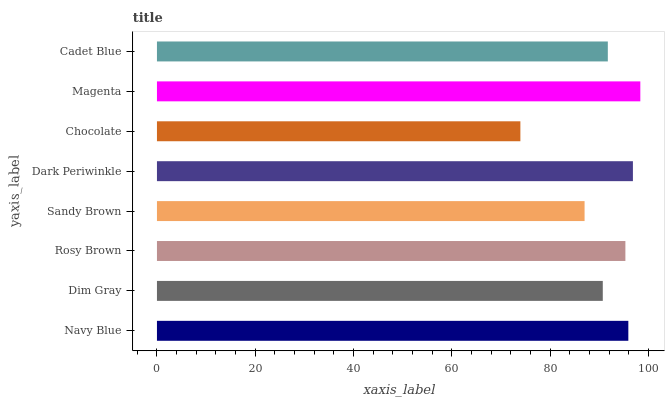Is Chocolate the minimum?
Answer yes or no. Yes. Is Magenta the maximum?
Answer yes or no. Yes. Is Dim Gray the minimum?
Answer yes or no. No. Is Dim Gray the maximum?
Answer yes or no. No. Is Navy Blue greater than Dim Gray?
Answer yes or no. Yes. Is Dim Gray less than Navy Blue?
Answer yes or no. Yes. Is Dim Gray greater than Navy Blue?
Answer yes or no. No. Is Navy Blue less than Dim Gray?
Answer yes or no. No. Is Rosy Brown the high median?
Answer yes or no. Yes. Is Cadet Blue the low median?
Answer yes or no. Yes. Is Sandy Brown the high median?
Answer yes or no. No. Is Magenta the low median?
Answer yes or no. No. 